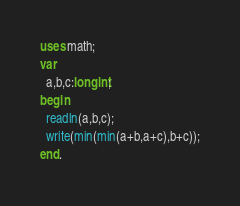<code> <loc_0><loc_0><loc_500><loc_500><_Pascal_>uses math;
var
  a,b,c:longint;
begin
  readln(a,b,c);
  write(min(min(a+b,a+c),b+c));
end.</code> 